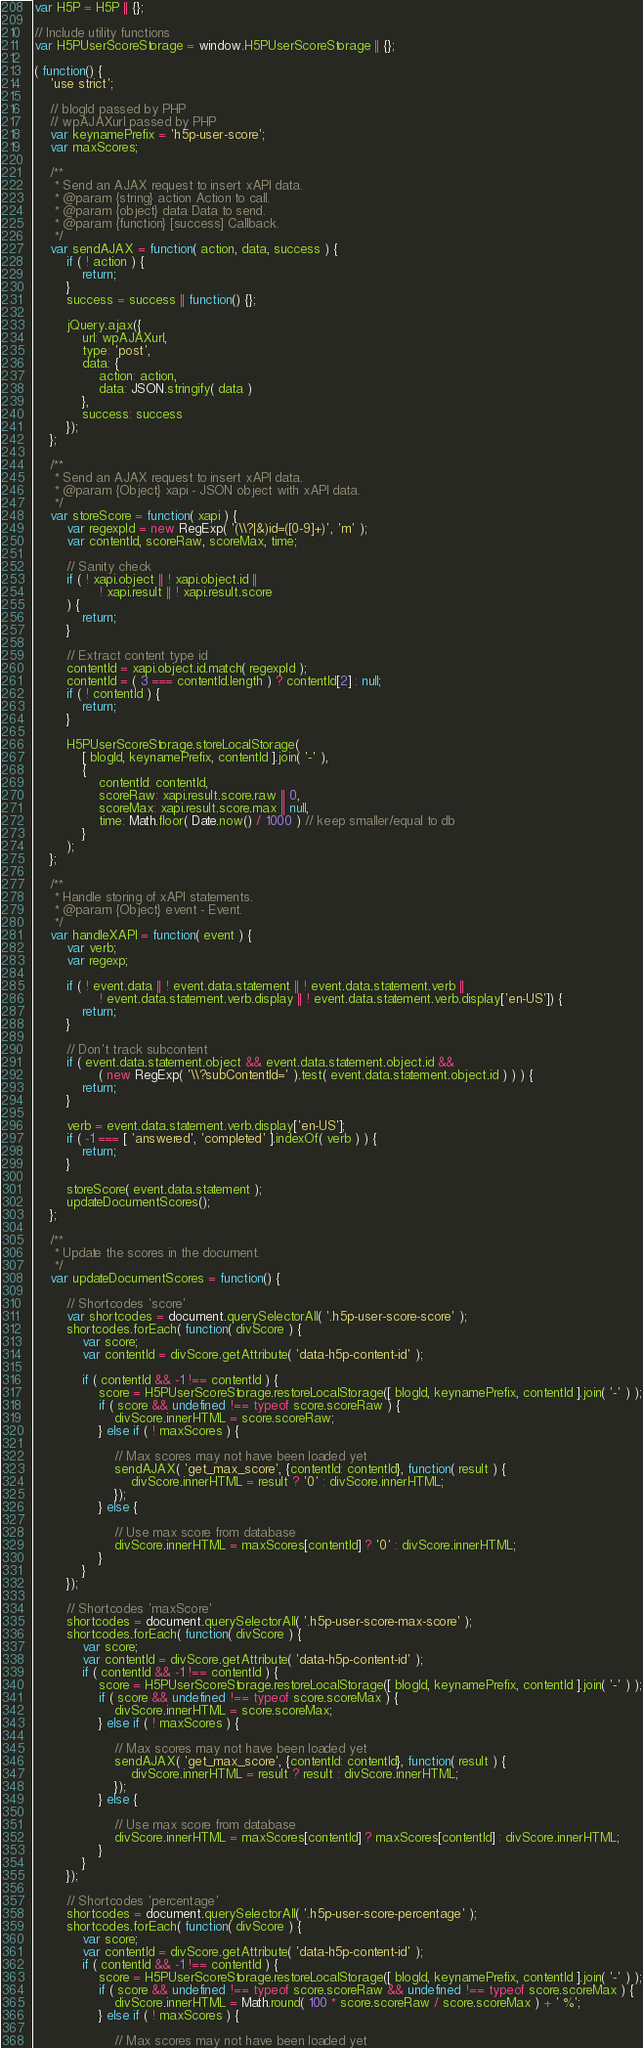Convert code to text. <code><loc_0><loc_0><loc_500><loc_500><_JavaScript_>var H5P = H5P || {};

// Include utility functions
var H5PUserScoreStorage = window.H5PUserScoreStorage || {};

( function() {
	'use strict';

	// blogId passed by PHP
	// wpAJAXurl passed by PHP
	var keynamePrefix = 'h5p-user-score';
	var maxScores;

	/**
	 * Send an AJAX request to insert xAPI data.
	 * @param {string} action Action to call.
	 * @param {object} data Data to send.
	 * @param {function} [success] Callback.
	 */
	var sendAJAX = function( action, data, success ) {
		if ( ! action ) {
			return;
		}
		success = success || function() {};

		jQuery.ajax({
			url: wpAJAXurl,
			type: 'post',
			data: {
				action: action,
				data: JSON.stringify( data )
			},
			success: success
		});
	};

	/**
	 * Send an AJAX request to insert xAPI data.
	 * @param {Object} xapi - JSON object with xAPI data.
	 */
	var storeScore = function( xapi ) {
		var regexpId = new RegExp( '(\\?|&)id=([0-9]+)', 'm' );
		var contentId, scoreRaw, scoreMax, time;

		// Sanity check
		if ( ! xapi.object || ! xapi.object.id ||
				! xapi.result || ! xapi.result.score
		) {
			return;
		}

		// Extract content type id
		contentId = xapi.object.id.match( regexpId );
		contentId = ( 3 === contentId.length ) ? contentId[2] : null;
		if ( ! contentId ) {
			return;
		}

		H5PUserScoreStorage.storeLocalStorage(
			[ blogId, keynamePrefix, contentId ].join( '-' ),
			{
				contentId: contentId,
				scoreRaw: xapi.result.score.raw || 0,
				scoreMax: xapi.result.score.max || null,
				time: Math.floor( Date.now() / 1000 ) // keep smaller/equal to db
			}
		);
	};

	/**
	 * Handle storing of xAPI statements.
	 * @param {Object} event - Event.
	 */
	var handleXAPI = function( event ) {
		var verb;
		var regexp;

		if ( ! event.data || ! event.data.statement || ! event.data.statement.verb ||
				! event.data.statement.verb.display || ! event.data.statement.verb.display['en-US']) {
			return;
		}

		// Don't track subcontent
		if ( event.data.statement.object && event.data.statement.object.id &&
				( new RegExp( '\\?subContentId=' ).test( event.data.statement.object.id ) ) ) {
			return;
		}

		verb = event.data.statement.verb.display['en-US'];
		if ( -1 === [ 'answered', 'completed' ].indexOf( verb ) ) {
			return;
		}

		storeScore( event.data.statement );
		updateDocumentScores();
	};

	/**
	 * Update the scores in the document.
	 */
	var updateDocumentScores = function() {

		// Shortcodes 'score'
		var shortcodes = document.querySelectorAll( '.h5p-user-score-score' );
		shortcodes.forEach( function( divScore ) {
			var score;
			var contentId = divScore.getAttribute( 'data-h5p-content-id' );

			if ( contentId && -1 !== contentId ) {
				score = H5PUserScoreStorage.restoreLocalStorage([ blogId, keynamePrefix, contentId ].join( '-' ) );
				if ( score && undefined !== typeof score.scoreRaw ) {
					divScore.innerHTML = score.scoreRaw;
				} else if ( ! maxScores ) {

					// Max scores may not have been loaded yet
					sendAJAX( 'get_max_score', {contentId: contentId}, function( result ) {
						divScore.innerHTML = result ? '0' : divScore.innerHTML;
					});
				} else {

					// Use max score from database
					divScore.innerHTML = maxScores[contentId] ? '0' : divScore.innerHTML;
				}
			}
		});

		// Shortcodes 'maxScore'
		shortcodes = document.querySelectorAll( '.h5p-user-score-max-score' );
		shortcodes.forEach( function( divScore ) {
			var score;
			var contentId = divScore.getAttribute( 'data-h5p-content-id' );
			if ( contentId && -1 !== contentId ) {
				score = H5PUserScoreStorage.restoreLocalStorage([ blogId, keynamePrefix, contentId ].join( '-' ) );
				if ( score && undefined !== typeof score.scoreMax ) {
					divScore.innerHTML = score.scoreMax;
				} else if ( ! maxScores ) {

					// Max scores may not have been loaded yet
					sendAJAX( 'get_max_score', {contentId: contentId}, function( result ) {
						divScore.innerHTML = result ? result : divScore.innerHTML;
					});
				} else {

					// Use max score from database
					divScore.innerHTML = maxScores[contentId] ? maxScores[contentId] : divScore.innerHTML;
				}
			}
		});

		// Shortcodes 'percentage'
		shortcodes = document.querySelectorAll( '.h5p-user-score-percentage' );
		shortcodes.forEach( function( divScore ) {
			var score;
			var contentId = divScore.getAttribute( 'data-h5p-content-id' );
			if ( contentId && -1 !== contentId ) {
				score = H5PUserScoreStorage.restoreLocalStorage([ blogId, keynamePrefix, contentId ].join( '-' ) );
				if ( score && undefined !== typeof score.scoreRaw && undefined !== typeof score.scoreMax ) {
					divScore.innerHTML = Math.round( 100 * score.scoreRaw / score.scoreMax ) + ' %';
				} else if ( ! maxScores ) {

					// Max scores may not have been loaded yet</code> 